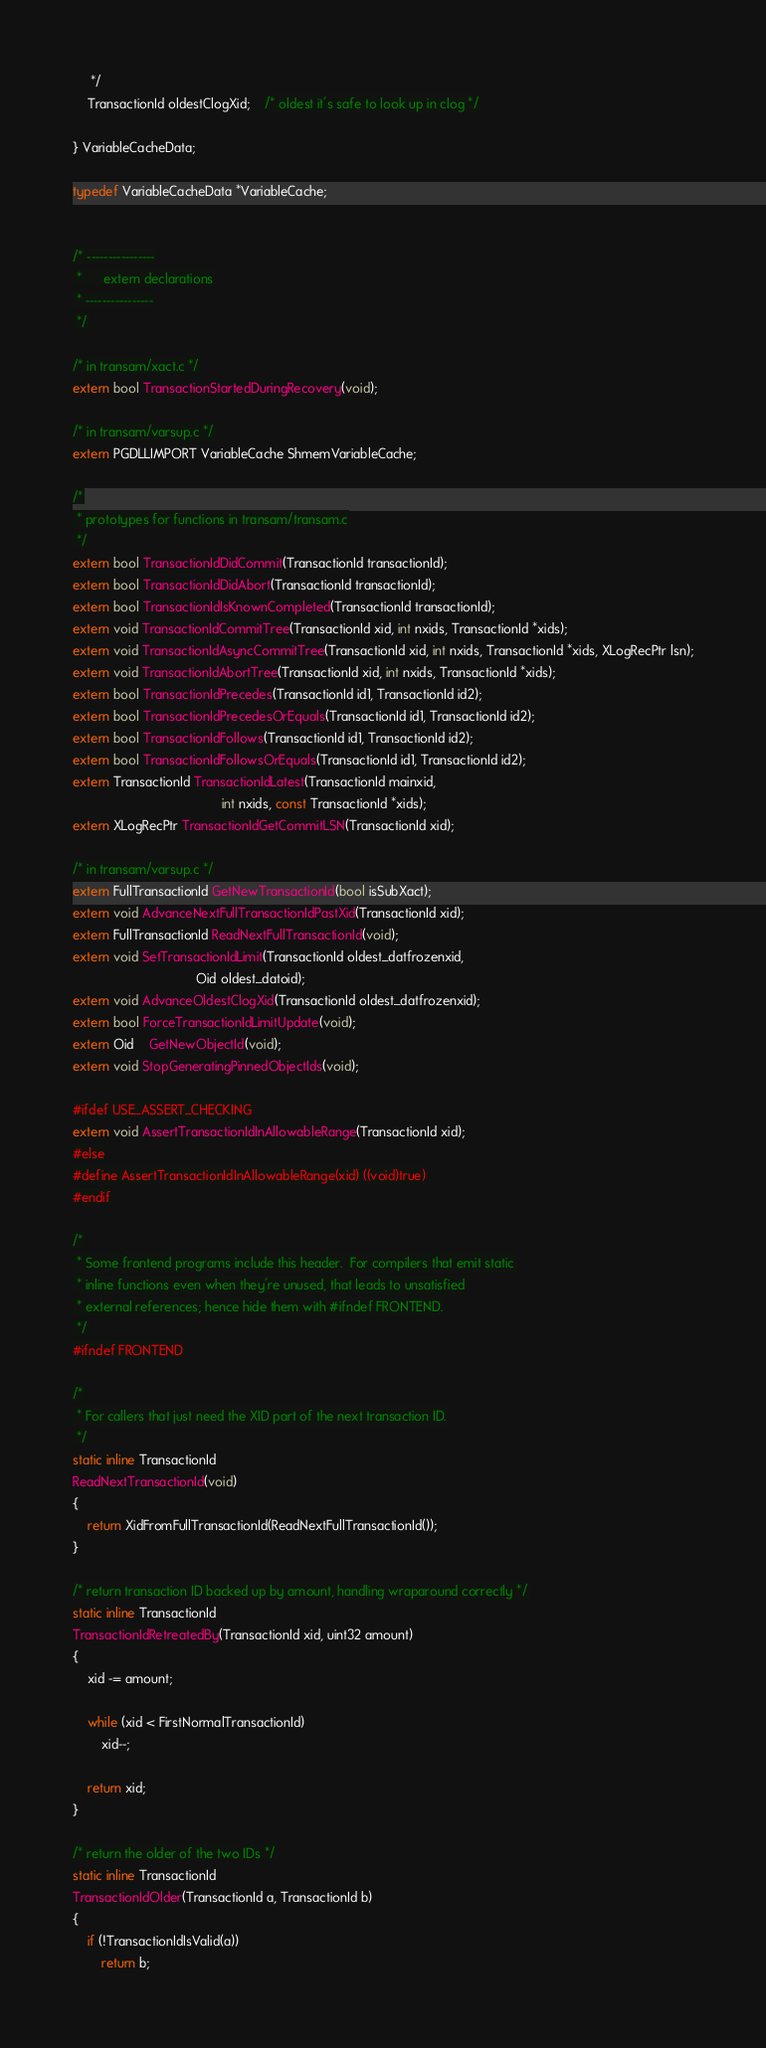Convert code to text. <code><loc_0><loc_0><loc_500><loc_500><_C_>	 */
	TransactionId oldestClogXid;	/* oldest it's safe to look up in clog */

} VariableCacheData;

typedef VariableCacheData *VariableCache;


/* ----------------
 *		extern declarations
 * ----------------
 */

/* in transam/xact.c */
extern bool TransactionStartedDuringRecovery(void);

/* in transam/varsup.c */
extern PGDLLIMPORT VariableCache ShmemVariableCache;

/*
 * prototypes for functions in transam/transam.c
 */
extern bool TransactionIdDidCommit(TransactionId transactionId);
extern bool TransactionIdDidAbort(TransactionId transactionId);
extern bool TransactionIdIsKnownCompleted(TransactionId transactionId);
extern void TransactionIdCommitTree(TransactionId xid, int nxids, TransactionId *xids);
extern void TransactionIdAsyncCommitTree(TransactionId xid, int nxids, TransactionId *xids, XLogRecPtr lsn);
extern void TransactionIdAbortTree(TransactionId xid, int nxids, TransactionId *xids);
extern bool TransactionIdPrecedes(TransactionId id1, TransactionId id2);
extern bool TransactionIdPrecedesOrEquals(TransactionId id1, TransactionId id2);
extern bool TransactionIdFollows(TransactionId id1, TransactionId id2);
extern bool TransactionIdFollowsOrEquals(TransactionId id1, TransactionId id2);
extern TransactionId TransactionIdLatest(TransactionId mainxid,
										 int nxids, const TransactionId *xids);
extern XLogRecPtr TransactionIdGetCommitLSN(TransactionId xid);

/* in transam/varsup.c */
extern FullTransactionId GetNewTransactionId(bool isSubXact);
extern void AdvanceNextFullTransactionIdPastXid(TransactionId xid);
extern FullTransactionId ReadNextFullTransactionId(void);
extern void SetTransactionIdLimit(TransactionId oldest_datfrozenxid,
								  Oid oldest_datoid);
extern void AdvanceOldestClogXid(TransactionId oldest_datfrozenxid);
extern bool ForceTransactionIdLimitUpdate(void);
extern Oid	GetNewObjectId(void);
extern void StopGeneratingPinnedObjectIds(void);

#ifdef USE_ASSERT_CHECKING
extern void AssertTransactionIdInAllowableRange(TransactionId xid);
#else
#define AssertTransactionIdInAllowableRange(xid) ((void)true)
#endif

/*
 * Some frontend programs include this header.  For compilers that emit static
 * inline functions even when they're unused, that leads to unsatisfied
 * external references; hence hide them with #ifndef FRONTEND.
 */
#ifndef FRONTEND

/*
 * For callers that just need the XID part of the next transaction ID.
 */
static inline TransactionId
ReadNextTransactionId(void)
{
	return XidFromFullTransactionId(ReadNextFullTransactionId());
}

/* return transaction ID backed up by amount, handling wraparound correctly */
static inline TransactionId
TransactionIdRetreatedBy(TransactionId xid, uint32 amount)
{
	xid -= amount;

	while (xid < FirstNormalTransactionId)
		xid--;

	return xid;
}

/* return the older of the two IDs */
static inline TransactionId
TransactionIdOlder(TransactionId a, TransactionId b)
{
	if (!TransactionIdIsValid(a))
		return b;
</code> 